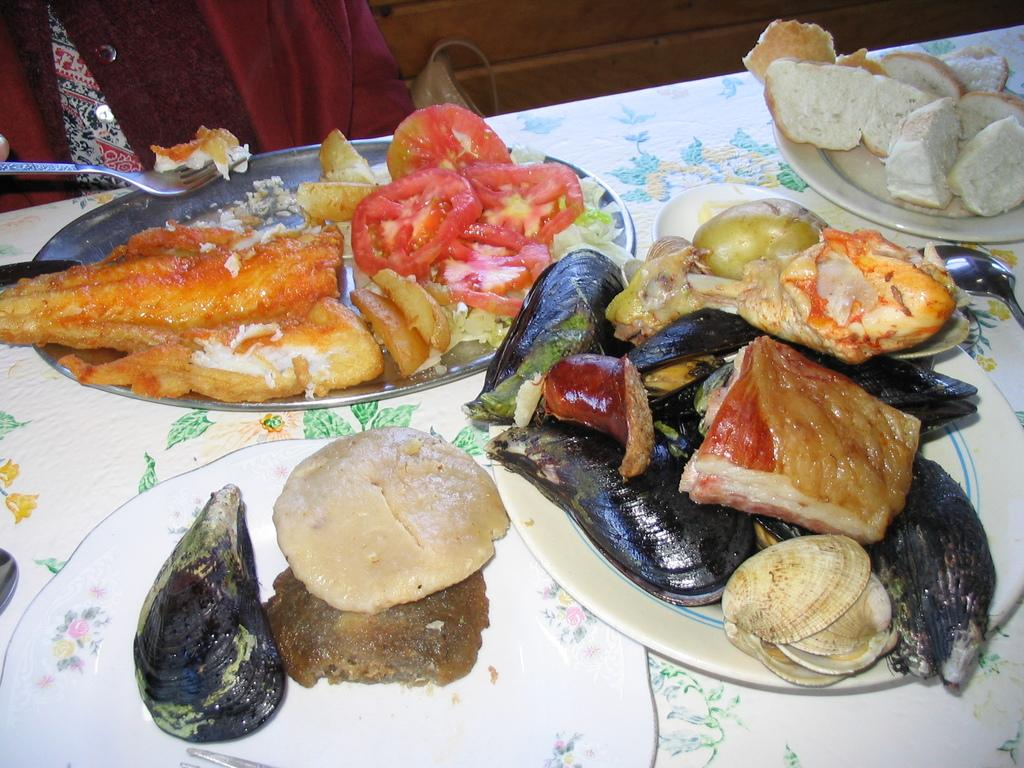What is the main piece of furniture in the image? There is a table in the image. What is covering the table? The table is covered with a cloth. What can be found on top of the table? There are plates, a platter, and various food items on the table. What is the person on the left side of the image holding? The person is holding a fork. What type of locket is the person wearing in the image? There is no person wearing a locket in the image. Can you describe the bear sitting next to the table in the image? There is no bear present in the image. 